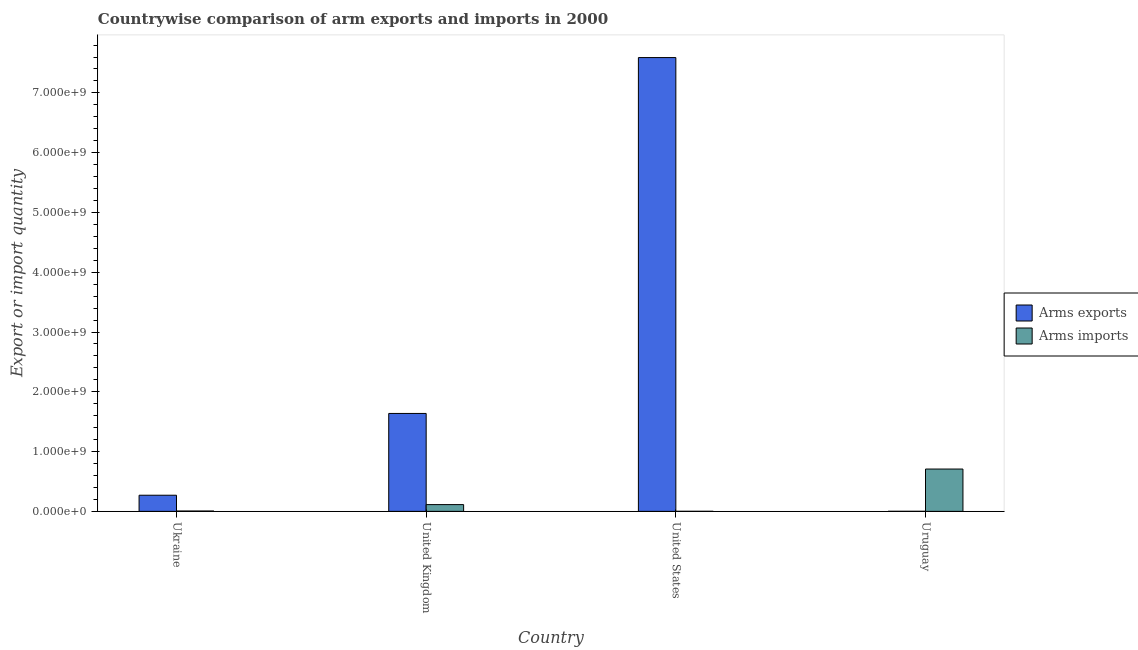How many groups of bars are there?
Make the answer very short. 4. Are the number of bars per tick equal to the number of legend labels?
Provide a short and direct response. Yes. Are the number of bars on each tick of the X-axis equal?
Give a very brief answer. Yes. How many bars are there on the 3rd tick from the left?
Give a very brief answer. 2. How many bars are there on the 3rd tick from the right?
Offer a terse response. 2. What is the arms imports in Ukraine?
Ensure brevity in your answer.  6.00e+06. Across all countries, what is the maximum arms exports?
Ensure brevity in your answer.  7.59e+09. Across all countries, what is the minimum arms imports?
Give a very brief answer. 1.00e+06. In which country was the arms exports maximum?
Give a very brief answer. United States. In which country was the arms imports minimum?
Your response must be concise. United States. What is the total arms exports in the graph?
Your answer should be compact. 9.50e+09. What is the difference between the arms imports in Ukraine and that in United States?
Your answer should be compact. 5.00e+06. What is the difference between the arms exports in Ukraine and the arms imports in United States?
Provide a succinct answer. 2.69e+08. What is the average arms exports per country?
Offer a very short reply. 2.38e+09. What is the difference between the arms imports and arms exports in United States?
Provide a short and direct response. -7.59e+09. What is the ratio of the arms imports in Ukraine to that in Uruguay?
Your answer should be very brief. 0.01. Is the difference between the arms imports in Ukraine and United Kingdom greater than the difference between the arms exports in Ukraine and United Kingdom?
Give a very brief answer. Yes. What is the difference between the highest and the second highest arms exports?
Provide a succinct answer. 5.95e+09. What is the difference between the highest and the lowest arms exports?
Ensure brevity in your answer.  7.59e+09. Is the sum of the arms imports in Ukraine and Uruguay greater than the maximum arms exports across all countries?
Provide a succinct answer. No. What does the 2nd bar from the left in United States represents?
Provide a short and direct response. Arms imports. What does the 1st bar from the right in Ukraine represents?
Make the answer very short. Arms imports. How many bars are there?
Give a very brief answer. 8. Are all the bars in the graph horizontal?
Offer a terse response. No. How many countries are there in the graph?
Your response must be concise. 4. Are the values on the major ticks of Y-axis written in scientific E-notation?
Provide a short and direct response. Yes. Does the graph contain grids?
Provide a succinct answer. No. Where does the legend appear in the graph?
Provide a succinct answer. Center right. How many legend labels are there?
Provide a succinct answer. 2. What is the title of the graph?
Provide a short and direct response. Countrywise comparison of arm exports and imports in 2000. Does "RDB nonconcessional" appear as one of the legend labels in the graph?
Your response must be concise. No. What is the label or title of the X-axis?
Make the answer very short. Country. What is the label or title of the Y-axis?
Keep it short and to the point. Export or import quantity. What is the Export or import quantity in Arms exports in Ukraine?
Make the answer very short. 2.70e+08. What is the Export or import quantity of Arms exports in United Kingdom?
Offer a terse response. 1.64e+09. What is the Export or import quantity of Arms imports in United Kingdom?
Make the answer very short. 1.13e+08. What is the Export or import quantity of Arms exports in United States?
Give a very brief answer. 7.59e+09. What is the Export or import quantity in Arms imports in United States?
Keep it short and to the point. 1.00e+06. What is the Export or import quantity of Arms imports in Uruguay?
Keep it short and to the point. 7.08e+08. Across all countries, what is the maximum Export or import quantity of Arms exports?
Ensure brevity in your answer.  7.59e+09. Across all countries, what is the maximum Export or import quantity in Arms imports?
Give a very brief answer. 7.08e+08. Across all countries, what is the minimum Export or import quantity of Arms imports?
Give a very brief answer. 1.00e+06. What is the total Export or import quantity in Arms exports in the graph?
Offer a terse response. 9.50e+09. What is the total Export or import quantity of Arms imports in the graph?
Your answer should be compact. 8.28e+08. What is the difference between the Export or import quantity in Arms exports in Ukraine and that in United Kingdom?
Make the answer very short. -1.37e+09. What is the difference between the Export or import quantity of Arms imports in Ukraine and that in United Kingdom?
Make the answer very short. -1.07e+08. What is the difference between the Export or import quantity of Arms exports in Ukraine and that in United States?
Provide a short and direct response. -7.32e+09. What is the difference between the Export or import quantity of Arms exports in Ukraine and that in Uruguay?
Keep it short and to the point. 2.69e+08. What is the difference between the Export or import quantity in Arms imports in Ukraine and that in Uruguay?
Ensure brevity in your answer.  -7.02e+08. What is the difference between the Export or import quantity in Arms exports in United Kingdom and that in United States?
Provide a succinct answer. -5.95e+09. What is the difference between the Export or import quantity of Arms imports in United Kingdom and that in United States?
Your answer should be compact. 1.12e+08. What is the difference between the Export or import quantity of Arms exports in United Kingdom and that in Uruguay?
Your answer should be very brief. 1.64e+09. What is the difference between the Export or import quantity of Arms imports in United Kingdom and that in Uruguay?
Ensure brevity in your answer.  -5.95e+08. What is the difference between the Export or import quantity of Arms exports in United States and that in Uruguay?
Provide a short and direct response. 7.59e+09. What is the difference between the Export or import quantity in Arms imports in United States and that in Uruguay?
Give a very brief answer. -7.07e+08. What is the difference between the Export or import quantity in Arms exports in Ukraine and the Export or import quantity in Arms imports in United Kingdom?
Your answer should be very brief. 1.57e+08. What is the difference between the Export or import quantity of Arms exports in Ukraine and the Export or import quantity of Arms imports in United States?
Provide a succinct answer. 2.69e+08. What is the difference between the Export or import quantity in Arms exports in Ukraine and the Export or import quantity in Arms imports in Uruguay?
Ensure brevity in your answer.  -4.38e+08. What is the difference between the Export or import quantity in Arms exports in United Kingdom and the Export or import quantity in Arms imports in United States?
Provide a succinct answer. 1.64e+09. What is the difference between the Export or import quantity of Arms exports in United Kingdom and the Export or import quantity of Arms imports in Uruguay?
Give a very brief answer. 9.30e+08. What is the difference between the Export or import quantity in Arms exports in United States and the Export or import quantity in Arms imports in Uruguay?
Your answer should be compact. 6.88e+09. What is the average Export or import quantity of Arms exports per country?
Offer a very short reply. 2.38e+09. What is the average Export or import quantity of Arms imports per country?
Your answer should be compact. 2.07e+08. What is the difference between the Export or import quantity of Arms exports and Export or import quantity of Arms imports in Ukraine?
Make the answer very short. 2.64e+08. What is the difference between the Export or import quantity of Arms exports and Export or import quantity of Arms imports in United Kingdom?
Ensure brevity in your answer.  1.52e+09. What is the difference between the Export or import quantity of Arms exports and Export or import quantity of Arms imports in United States?
Offer a very short reply. 7.59e+09. What is the difference between the Export or import quantity of Arms exports and Export or import quantity of Arms imports in Uruguay?
Your response must be concise. -7.07e+08. What is the ratio of the Export or import quantity in Arms exports in Ukraine to that in United Kingdom?
Make the answer very short. 0.16. What is the ratio of the Export or import quantity in Arms imports in Ukraine to that in United Kingdom?
Offer a terse response. 0.05. What is the ratio of the Export or import quantity of Arms exports in Ukraine to that in United States?
Provide a short and direct response. 0.04. What is the ratio of the Export or import quantity of Arms imports in Ukraine to that in United States?
Provide a short and direct response. 6. What is the ratio of the Export or import quantity of Arms exports in Ukraine to that in Uruguay?
Provide a succinct answer. 270. What is the ratio of the Export or import quantity of Arms imports in Ukraine to that in Uruguay?
Give a very brief answer. 0.01. What is the ratio of the Export or import quantity of Arms exports in United Kingdom to that in United States?
Keep it short and to the point. 0.22. What is the ratio of the Export or import quantity of Arms imports in United Kingdom to that in United States?
Ensure brevity in your answer.  113. What is the ratio of the Export or import quantity in Arms exports in United Kingdom to that in Uruguay?
Give a very brief answer. 1638. What is the ratio of the Export or import quantity of Arms imports in United Kingdom to that in Uruguay?
Offer a very short reply. 0.16. What is the ratio of the Export or import quantity in Arms exports in United States to that in Uruguay?
Make the answer very short. 7591. What is the ratio of the Export or import quantity in Arms imports in United States to that in Uruguay?
Make the answer very short. 0. What is the difference between the highest and the second highest Export or import quantity of Arms exports?
Your answer should be compact. 5.95e+09. What is the difference between the highest and the second highest Export or import quantity of Arms imports?
Offer a terse response. 5.95e+08. What is the difference between the highest and the lowest Export or import quantity in Arms exports?
Your response must be concise. 7.59e+09. What is the difference between the highest and the lowest Export or import quantity in Arms imports?
Your answer should be very brief. 7.07e+08. 